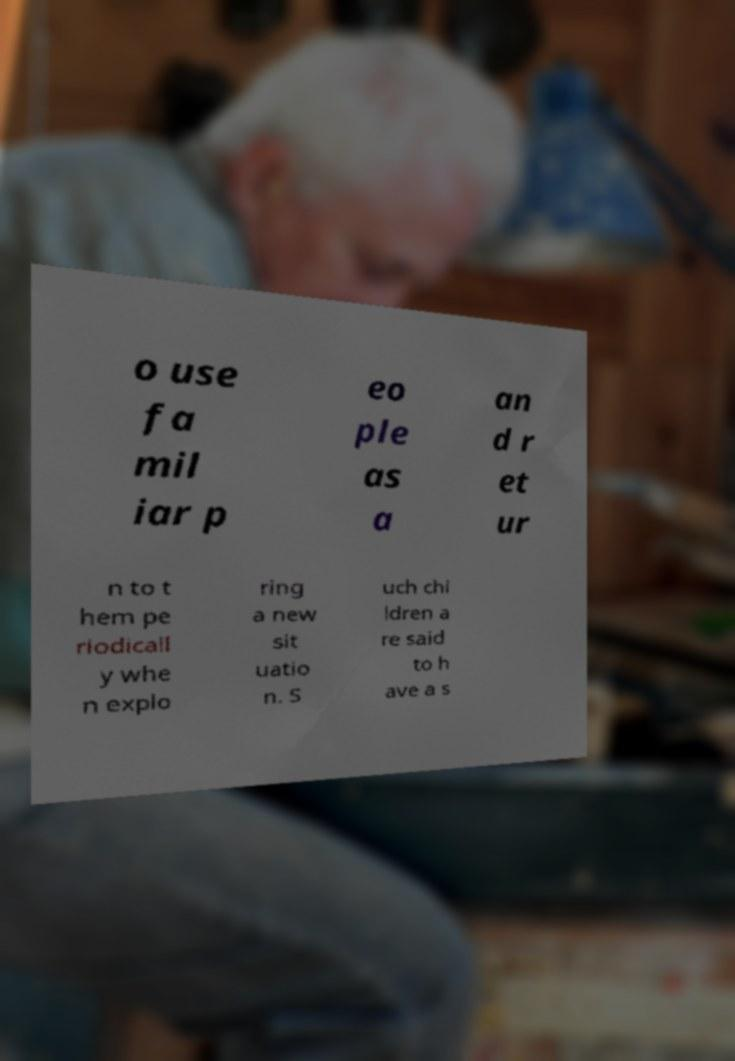Can you accurately transcribe the text from the provided image for me? o use fa mil iar p eo ple as a an d r et ur n to t hem pe riodicall y whe n explo ring a new sit uatio n. S uch chi ldren a re said to h ave a s 